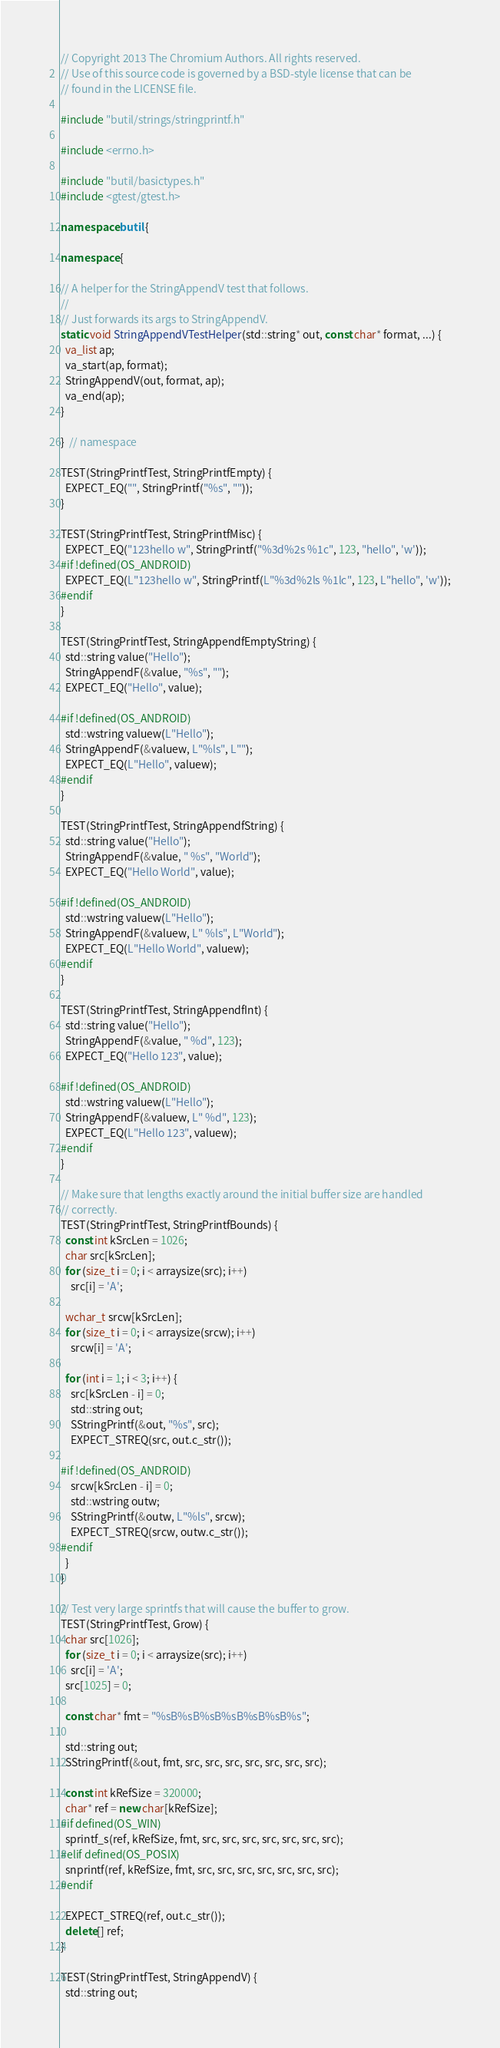Convert code to text. <code><loc_0><loc_0><loc_500><loc_500><_C++_>// Copyright 2013 The Chromium Authors. All rights reserved.
// Use of this source code is governed by a BSD-style license that can be
// found in the LICENSE file.

#include "butil/strings/stringprintf.h"

#include <errno.h>

#include "butil/basictypes.h"
#include <gtest/gtest.h>

namespace butil {

namespace {

// A helper for the StringAppendV test that follows.
//
// Just forwards its args to StringAppendV.
static void StringAppendVTestHelper(std::string* out, const char* format, ...) {
  va_list ap;
  va_start(ap, format);
  StringAppendV(out, format, ap);
  va_end(ap);
}

}  // namespace

TEST(StringPrintfTest, StringPrintfEmpty) {
  EXPECT_EQ("", StringPrintf("%s", ""));
}

TEST(StringPrintfTest, StringPrintfMisc) {
  EXPECT_EQ("123hello w", StringPrintf("%3d%2s %1c", 123, "hello", 'w'));
#if !defined(OS_ANDROID)
  EXPECT_EQ(L"123hello w", StringPrintf(L"%3d%2ls %1lc", 123, L"hello", 'w'));
#endif
}

TEST(StringPrintfTest, StringAppendfEmptyString) {
  std::string value("Hello");
  StringAppendF(&value, "%s", "");
  EXPECT_EQ("Hello", value);

#if !defined(OS_ANDROID)
  std::wstring valuew(L"Hello");
  StringAppendF(&valuew, L"%ls", L"");
  EXPECT_EQ(L"Hello", valuew);
#endif
}

TEST(StringPrintfTest, StringAppendfString) {
  std::string value("Hello");
  StringAppendF(&value, " %s", "World");
  EXPECT_EQ("Hello World", value);

#if !defined(OS_ANDROID)
  std::wstring valuew(L"Hello");
  StringAppendF(&valuew, L" %ls", L"World");
  EXPECT_EQ(L"Hello World", valuew);
#endif
}

TEST(StringPrintfTest, StringAppendfInt) {
  std::string value("Hello");
  StringAppendF(&value, " %d", 123);
  EXPECT_EQ("Hello 123", value);

#if !defined(OS_ANDROID)
  std::wstring valuew(L"Hello");
  StringAppendF(&valuew, L" %d", 123);
  EXPECT_EQ(L"Hello 123", valuew);
#endif
}

// Make sure that lengths exactly around the initial buffer size are handled
// correctly.
TEST(StringPrintfTest, StringPrintfBounds) {
  const int kSrcLen = 1026;
  char src[kSrcLen];
  for (size_t i = 0; i < arraysize(src); i++)
    src[i] = 'A';

  wchar_t srcw[kSrcLen];
  for (size_t i = 0; i < arraysize(srcw); i++)
    srcw[i] = 'A';

  for (int i = 1; i < 3; i++) {
    src[kSrcLen - i] = 0;
    std::string out;
    SStringPrintf(&out, "%s", src);
    EXPECT_STREQ(src, out.c_str());

#if !defined(OS_ANDROID)
    srcw[kSrcLen - i] = 0;
    std::wstring outw;
    SStringPrintf(&outw, L"%ls", srcw);
    EXPECT_STREQ(srcw, outw.c_str());
#endif
  }
}

// Test very large sprintfs that will cause the buffer to grow.
TEST(StringPrintfTest, Grow) {
  char src[1026];
  for (size_t i = 0; i < arraysize(src); i++)
    src[i] = 'A';
  src[1025] = 0;

  const char* fmt = "%sB%sB%sB%sB%sB%sB%s";

  std::string out;
  SStringPrintf(&out, fmt, src, src, src, src, src, src, src);

  const int kRefSize = 320000;
  char* ref = new char[kRefSize];
#if defined(OS_WIN)
  sprintf_s(ref, kRefSize, fmt, src, src, src, src, src, src, src);
#elif defined(OS_POSIX)
  snprintf(ref, kRefSize, fmt, src, src, src, src, src, src, src);
#endif

  EXPECT_STREQ(ref, out.c_str());
  delete[] ref;
}

TEST(StringPrintfTest, StringAppendV) {
  std::string out;</code> 